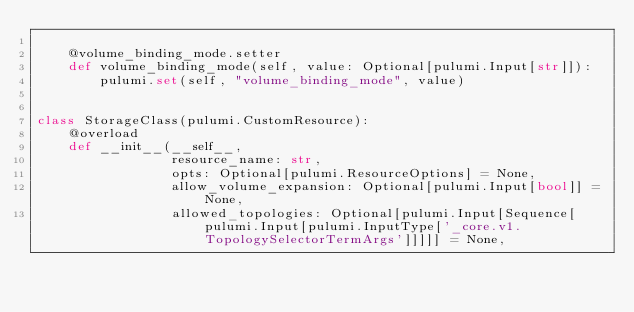Convert code to text. <code><loc_0><loc_0><loc_500><loc_500><_Python_>
    @volume_binding_mode.setter
    def volume_binding_mode(self, value: Optional[pulumi.Input[str]]):
        pulumi.set(self, "volume_binding_mode", value)


class StorageClass(pulumi.CustomResource):
    @overload
    def __init__(__self__,
                 resource_name: str,
                 opts: Optional[pulumi.ResourceOptions] = None,
                 allow_volume_expansion: Optional[pulumi.Input[bool]] = None,
                 allowed_topologies: Optional[pulumi.Input[Sequence[pulumi.Input[pulumi.InputType['_core.v1.TopologySelectorTermArgs']]]]] = None,</code> 